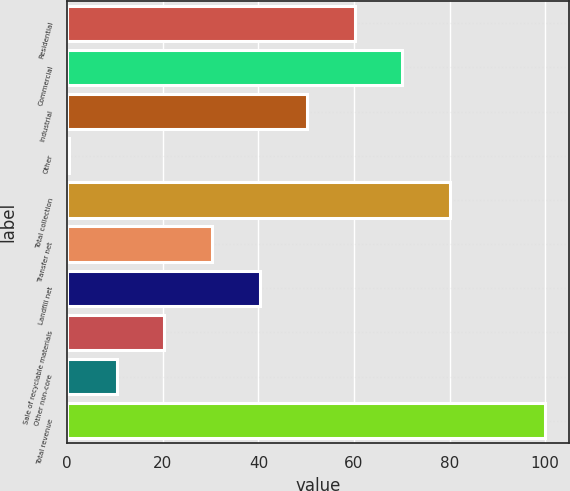Convert chart. <chart><loc_0><loc_0><loc_500><loc_500><bar_chart><fcel>Residential<fcel>Commercial<fcel>Industrial<fcel>Other<fcel>Total collection<fcel>Transfer net<fcel>Landfill net<fcel>Sale of recyclable materials<fcel>Other non-core<fcel>Total revenue<nl><fcel>60.16<fcel>70.12<fcel>50.2<fcel>0.4<fcel>80.08<fcel>30.28<fcel>40.24<fcel>20.32<fcel>10.36<fcel>100<nl></chart> 